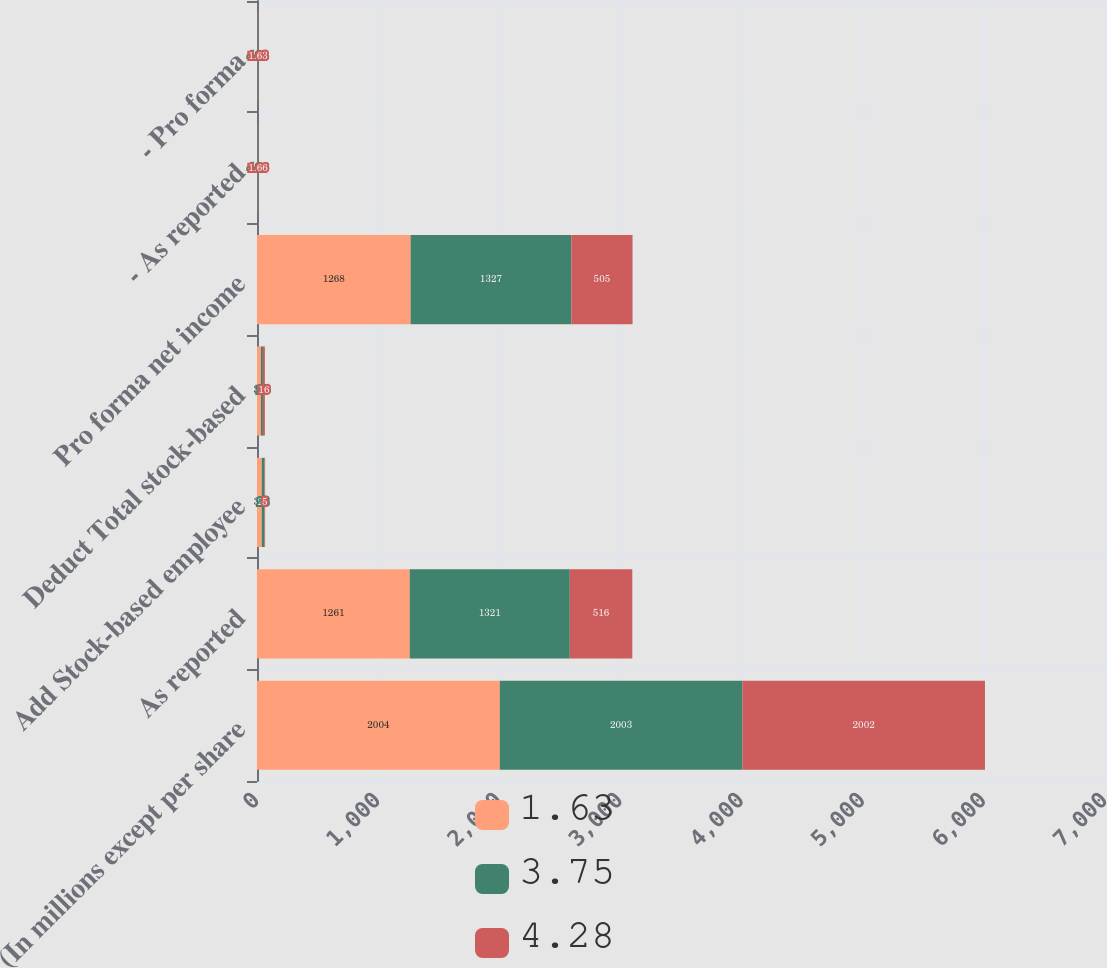Convert chart. <chart><loc_0><loc_0><loc_500><loc_500><stacked_bar_chart><ecel><fcel>(In millions except per share<fcel>As reported<fcel>Add Stock-based employee<fcel>Deduct Total stock-based<fcel>Pro forma net income<fcel>- As reported<fcel>- Pro forma<nl><fcel>1.63<fcel>2004<fcel>1261<fcel>39<fcel>32<fcel>1268<fcel>3.75<fcel>3.77<nl><fcel>3.75<fcel>2003<fcel>1321<fcel>23<fcel>17<fcel>1327<fcel>4.26<fcel>4.28<nl><fcel>4.28<fcel>2002<fcel>516<fcel>5<fcel>16<fcel>505<fcel>1.66<fcel>1.63<nl></chart> 